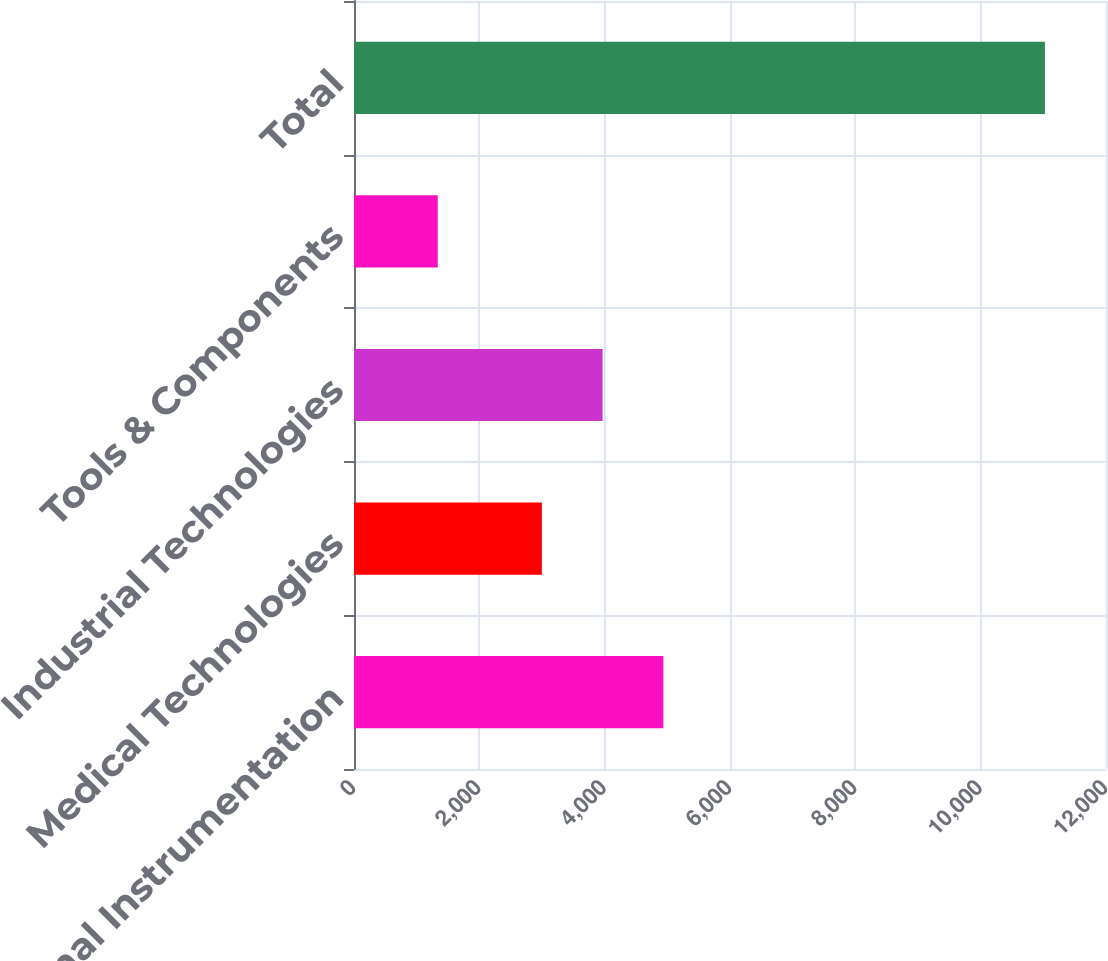Convert chart to OTSL. <chart><loc_0><loc_0><loc_500><loc_500><bar_chart><fcel>Professional Instrumentation<fcel>Medical Technologies<fcel>Industrial Technologies<fcel>Tools & Components<fcel>Total<nl><fcel>4935.86<fcel>2998<fcel>3966.93<fcel>1336.6<fcel>11025.9<nl></chart> 